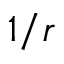<formula> <loc_0><loc_0><loc_500><loc_500>1 / r</formula> 